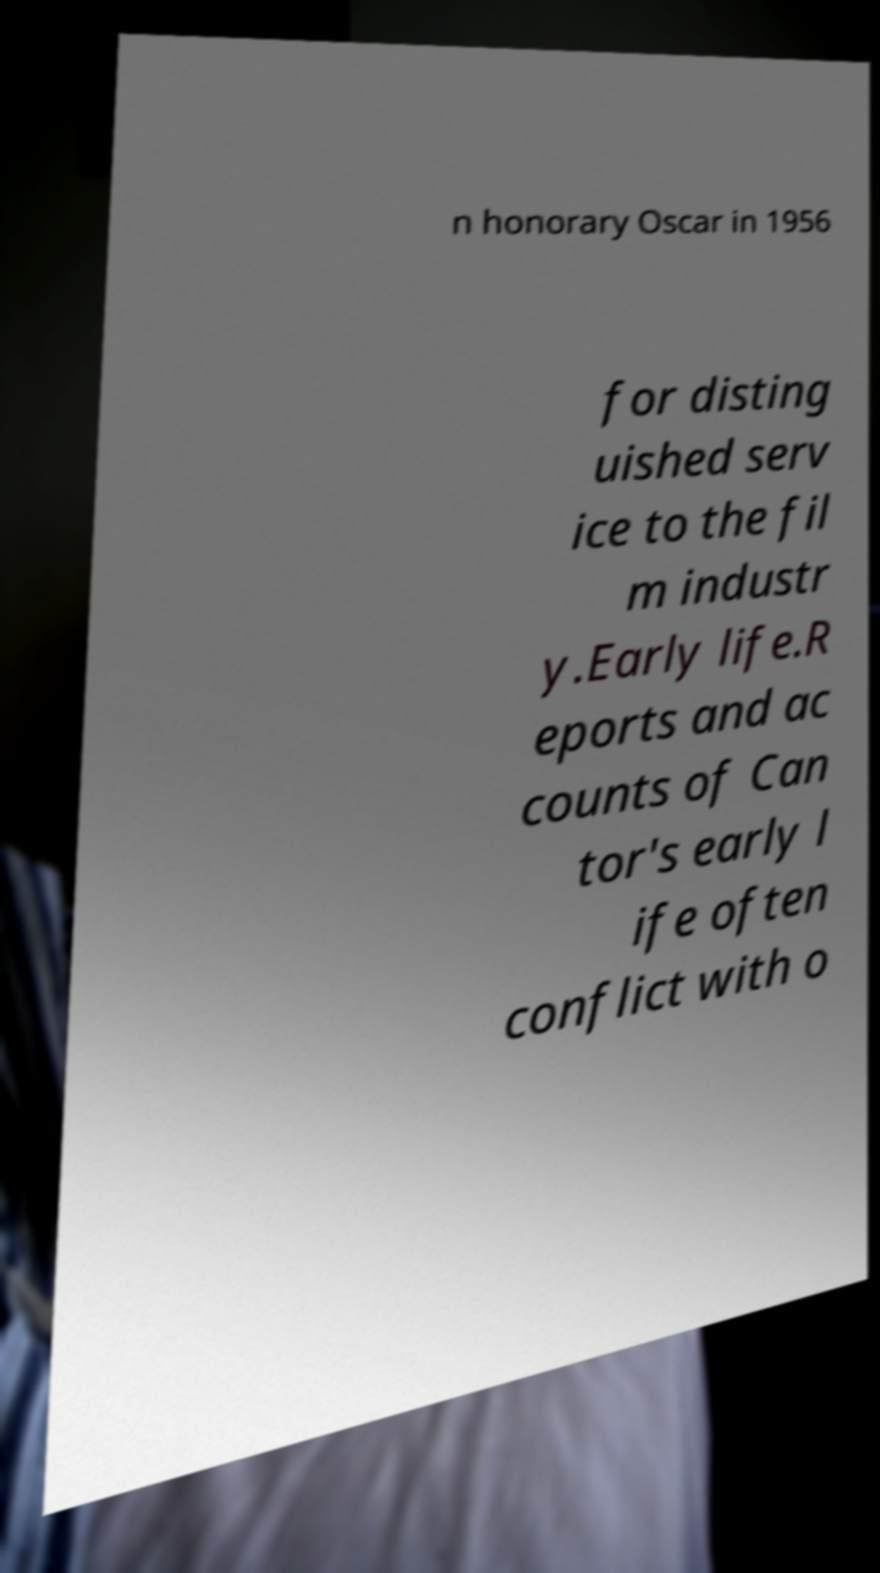Could you assist in decoding the text presented in this image and type it out clearly? n honorary Oscar in 1956 for disting uished serv ice to the fil m industr y.Early life.R eports and ac counts of Can tor's early l ife often conflict with o 